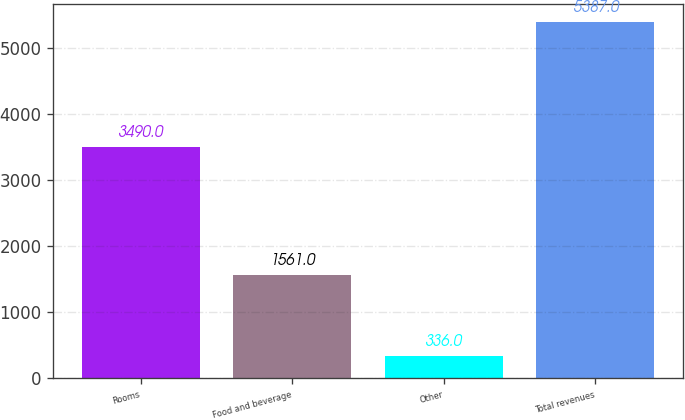Convert chart to OTSL. <chart><loc_0><loc_0><loc_500><loc_500><bar_chart><fcel>Rooms<fcel>Food and beverage<fcel>Other<fcel>Total revenues<nl><fcel>3490<fcel>1561<fcel>336<fcel>5387<nl></chart> 